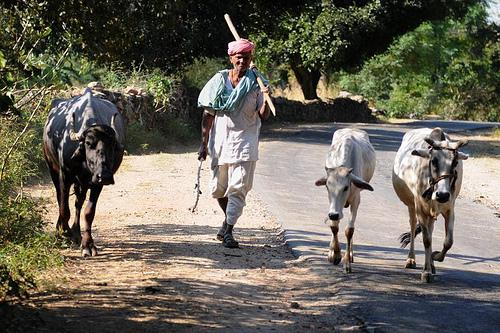Question: what is the color of the man's scarf?
Choices:
A. Green.
B. Red.
C. Blue.
D. Yellow.
Answer with the letter. Answer: A Question: what are the color of the trees?
Choices:
A. Brown.
B. Yellow.
C. Orange.
D. Green.
Answer with the letter. Answer: D Question: who is walking with the cows?
Choices:
A. Ranch hand.
B. Herder.
C. Man.
D. Cowboy.
Answer with the letter. Answer: C Question: what are the color of the cows?
Choices:
A. Black.
B. White.
C. White and brown.
D. Brown.
Answer with the letter. Answer: C 